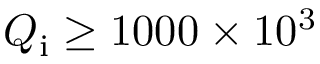Convert formula to latex. <formula><loc_0><loc_0><loc_500><loc_500>Q _ { i } \geq 1 0 0 0 \times 1 0 ^ { 3 }</formula> 